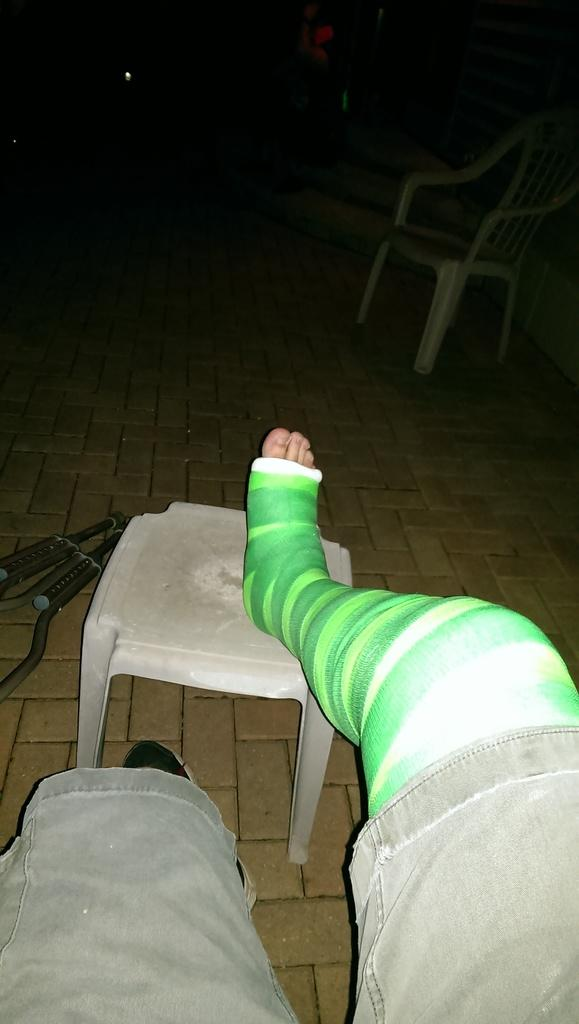What can be seen in the image that belongs to people? There are legs of people in the image. What type of furniture is present in the image? There is a chair in the image. What is on the floor in the image? There are objects on the floor in the image. How would you describe the lighting in the image? The background of the image is dark. Can you describe any other furniture visible in the image? There is another chair visible in the background of the image. What type of meal is being prepared on the floor in the image? There is no meal preparation visible in the image; it only shows legs of people, a chair, objects on the floor, and another chair in the background. Are there any shoes visible in the image? There is no mention of shoes in the provided facts, and they are not visible in the image. 